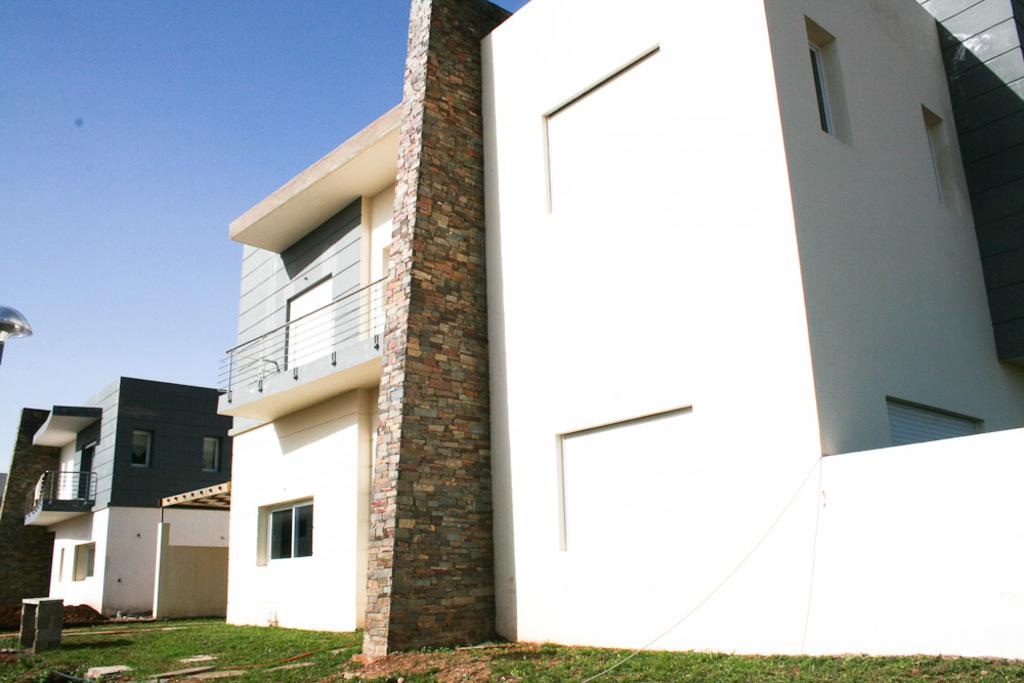What type of structures can be seen in the image? There are buildings in the image. What is the purpose of the barrier in the image? There is a fence in the image, which serves as a barrier or boundary. What type of seating is present in the image? There is a bench in the image. What type of vegetation is visible in the image? There is grass in the image. What is visible at the top of the image? The sky is visible at the top of the image. What type of apparel are the girls wearing in the image? There are no girls present in the image, so it is not possible to determine what type of apparel they might be wearing. What shape is the bench in the image? The shape of the bench cannot be determined from the image alone, as it is a two-dimensional representation. 